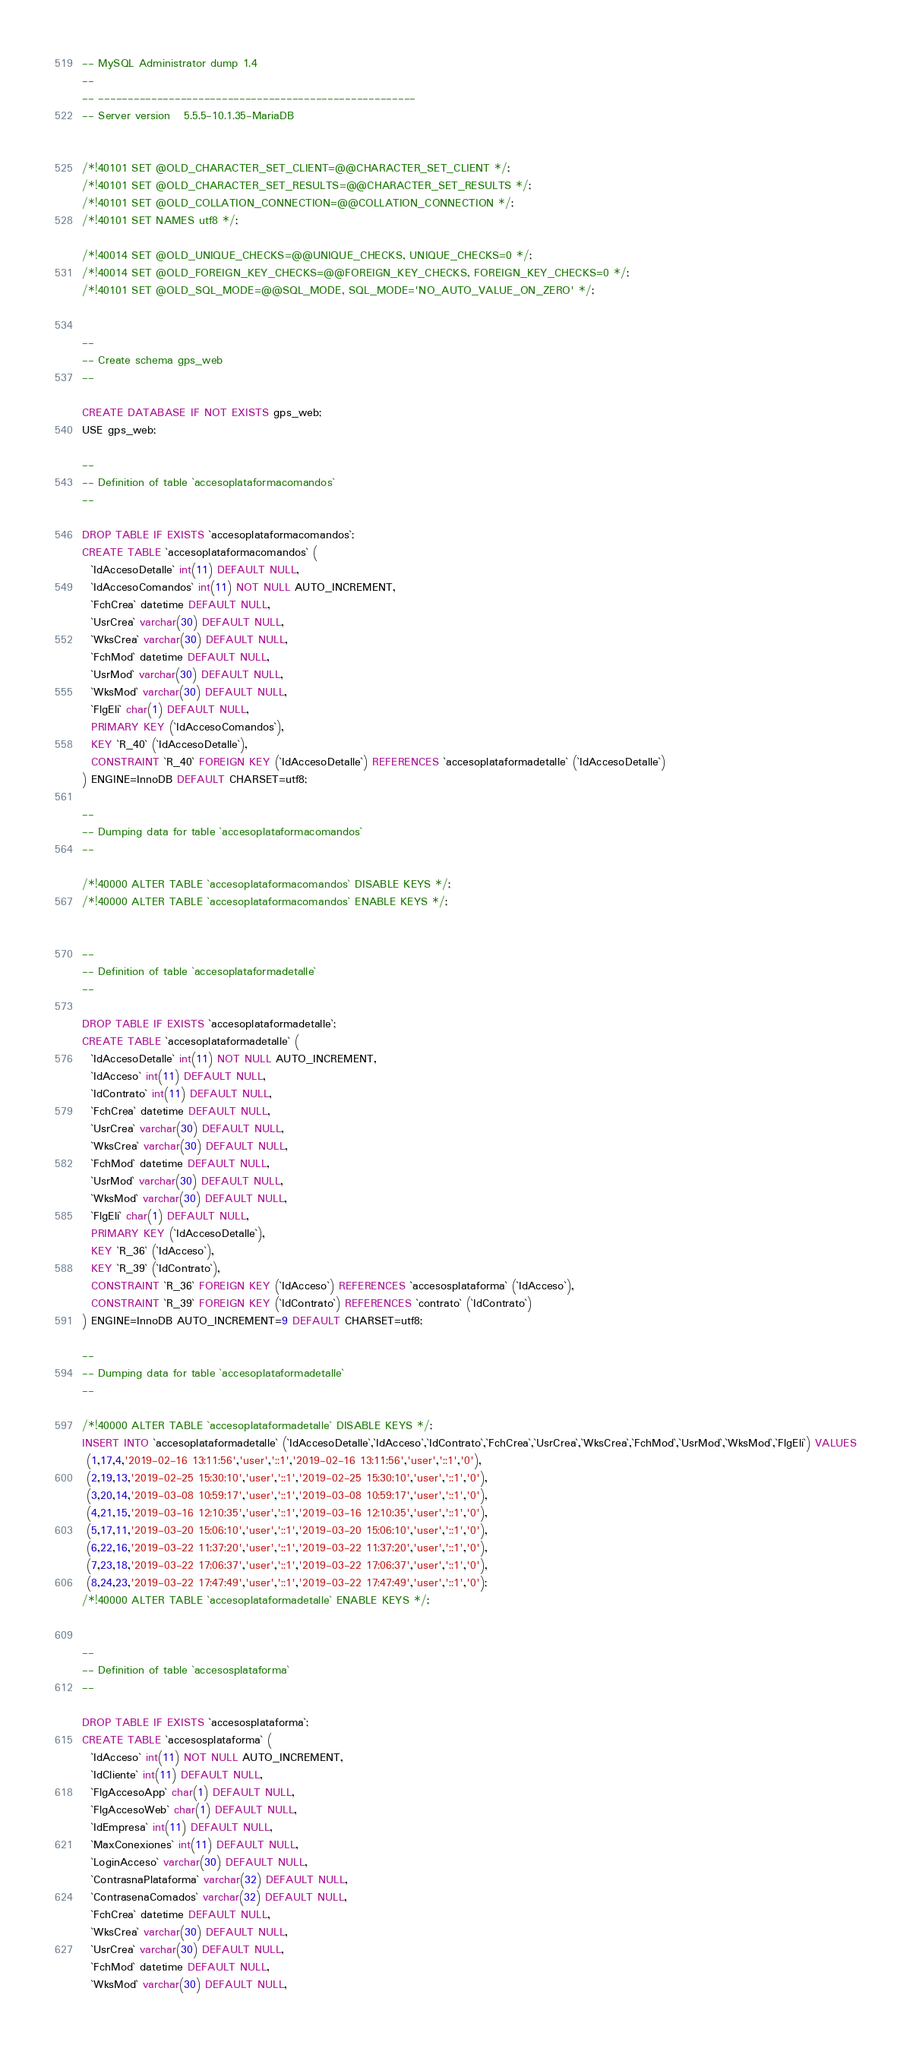<code> <loc_0><loc_0><loc_500><loc_500><_SQL_>-- MySQL Administrator dump 1.4
--
-- ------------------------------------------------------
-- Server version	5.5.5-10.1.35-MariaDB


/*!40101 SET @OLD_CHARACTER_SET_CLIENT=@@CHARACTER_SET_CLIENT */;
/*!40101 SET @OLD_CHARACTER_SET_RESULTS=@@CHARACTER_SET_RESULTS */;
/*!40101 SET @OLD_COLLATION_CONNECTION=@@COLLATION_CONNECTION */;
/*!40101 SET NAMES utf8 */;

/*!40014 SET @OLD_UNIQUE_CHECKS=@@UNIQUE_CHECKS, UNIQUE_CHECKS=0 */;
/*!40014 SET @OLD_FOREIGN_KEY_CHECKS=@@FOREIGN_KEY_CHECKS, FOREIGN_KEY_CHECKS=0 */;
/*!40101 SET @OLD_SQL_MODE=@@SQL_MODE, SQL_MODE='NO_AUTO_VALUE_ON_ZERO' */;


--
-- Create schema gps_web
--

CREATE DATABASE IF NOT EXISTS gps_web;
USE gps_web;

--
-- Definition of table `accesoplataformacomandos`
--

DROP TABLE IF EXISTS `accesoplataformacomandos`;
CREATE TABLE `accesoplataformacomandos` (
  `IdAccesoDetalle` int(11) DEFAULT NULL,
  `IdAccesoComandos` int(11) NOT NULL AUTO_INCREMENT,
  `FchCrea` datetime DEFAULT NULL,
  `UsrCrea` varchar(30) DEFAULT NULL,
  `WksCrea` varchar(30) DEFAULT NULL,
  `FchMod` datetime DEFAULT NULL,
  `UsrMod` varchar(30) DEFAULT NULL,
  `WksMod` varchar(30) DEFAULT NULL,
  `FlgEli` char(1) DEFAULT NULL,
  PRIMARY KEY (`IdAccesoComandos`),
  KEY `R_40` (`IdAccesoDetalle`),
  CONSTRAINT `R_40` FOREIGN KEY (`IdAccesoDetalle`) REFERENCES `accesoplataformadetalle` (`IdAccesoDetalle`)
) ENGINE=InnoDB DEFAULT CHARSET=utf8;

--
-- Dumping data for table `accesoplataformacomandos`
--

/*!40000 ALTER TABLE `accesoplataformacomandos` DISABLE KEYS */;
/*!40000 ALTER TABLE `accesoplataformacomandos` ENABLE KEYS */;


--
-- Definition of table `accesoplataformadetalle`
--

DROP TABLE IF EXISTS `accesoplataformadetalle`;
CREATE TABLE `accesoplataformadetalle` (
  `IdAccesoDetalle` int(11) NOT NULL AUTO_INCREMENT,
  `IdAcceso` int(11) DEFAULT NULL,
  `IdContrato` int(11) DEFAULT NULL,
  `FchCrea` datetime DEFAULT NULL,
  `UsrCrea` varchar(30) DEFAULT NULL,
  `WksCrea` varchar(30) DEFAULT NULL,
  `FchMod` datetime DEFAULT NULL,
  `UsrMod` varchar(30) DEFAULT NULL,
  `WksMod` varchar(30) DEFAULT NULL,
  `FlgEli` char(1) DEFAULT NULL,
  PRIMARY KEY (`IdAccesoDetalle`),
  KEY `R_36` (`IdAcceso`),
  KEY `R_39` (`IdContrato`),
  CONSTRAINT `R_36` FOREIGN KEY (`IdAcceso`) REFERENCES `accesosplataforma` (`IdAcceso`),
  CONSTRAINT `R_39` FOREIGN KEY (`IdContrato`) REFERENCES `contrato` (`IdContrato`)
) ENGINE=InnoDB AUTO_INCREMENT=9 DEFAULT CHARSET=utf8;

--
-- Dumping data for table `accesoplataformadetalle`
--

/*!40000 ALTER TABLE `accesoplataformadetalle` DISABLE KEYS */;
INSERT INTO `accesoplataformadetalle` (`IdAccesoDetalle`,`IdAcceso`,`IdContrato`,`FchCrea`,`UsrCrea`,`WksCrea`,`FchMod`,`UsrMod`,`WksMod`,`FlgEli`) VALUES 
 (1,17,4,'2019-02-16 13:11:56','user','::1','2019-02-16 13:11:56','user','::1','0'),
 (2,19,13,'2019-02-25 15:30:10','user','::1','2019-02-25 15:30:10','user','::1','0'),
 (3,20,14,'2019-03-08 10:59:17','user','::1','2019-03-08 10:59:17','user','::1','0'),
 (4,21,15,'2019-03-16 12:10:35','user','::1','2019-03-16 12:10:35','user','::1','0'),
 (5,17,11,'2019-03-20 15:06:10','user','::1','2019-03-20 15:06:10','user','::1','0'),
 (6,22,16,'2019-03-22 11:37:20','user','::1','2019-03-22 11:37:20','user','::1','0'),
 (7,23,18,'2019-03-22 17:06:37','user','::1','2019-03-22 17:06:37','user','::1','0'),
 (8,24,23,'2019-03-22 17:47:49','user','::1','2019-03-22 17:47:49','user','::1','0');
/*!40000 ALTER TABLE `accesoplataformadetalle` ENABLE KEYS */;


--
-- Definition of table `accesosplataforma`
--

DROP TABLE IF EXISTS `accesosplataforma`;
CREATE TABLE `accesosplataforma` (
  `IdAcceso` int(11) NOT NULL AUTO_INCREMENT,
  `IdCliente` int(11) DEFAULT NULL,
  `FlgAccesoApp` char(1) DEFAULT NULL,
  `FlgAccesoWeb` char(1) DEFAULT NULL,
  `IdEmpresa` int(11) DEFAULT NULL,
  `MaxConexiones` int(11) DEFAULT NULL,
  `LoginAcceso` varchar(30) DEFAULT NULL,
  `ContrasnaPlataforma` varchar(32) DEFAULT NULL,
  `ContrasenaComados` varchar(32) DEFAULT NULL,
  `FchCrea` datetime DEFAULT NULL,
  `WksCrea` varchar(30) DEFAULT NULL,
  `UsrCrea` varchar(30) DEFAULT NULL,
  `FchMod` datetime DEFAULT NULL,
  `WksMod` varchar(30) DEFAULT NULL,</code> 